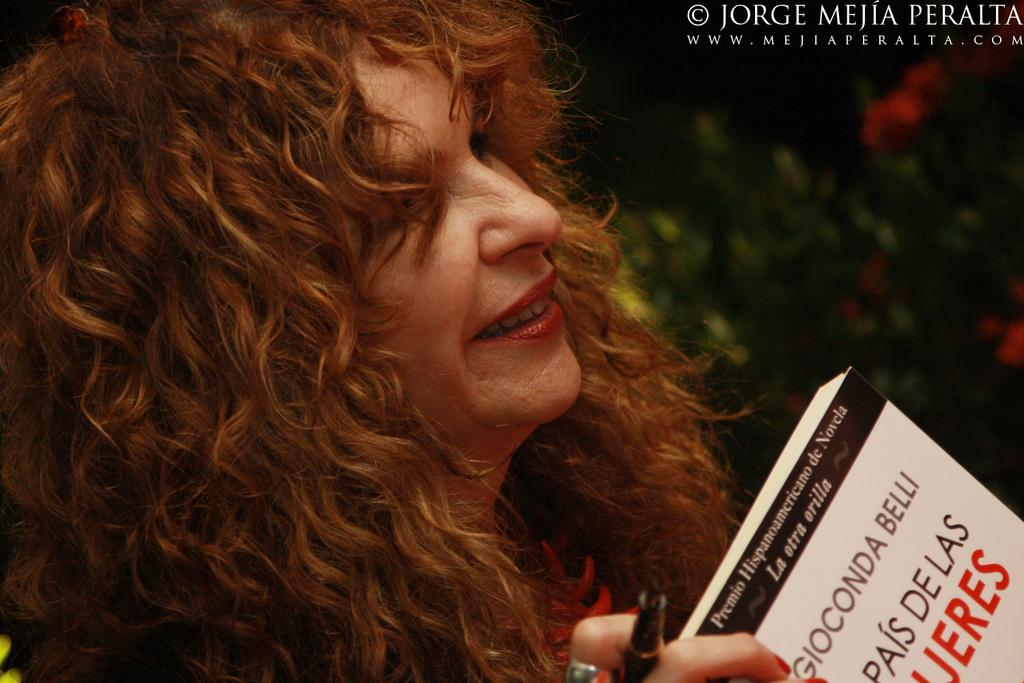What is the person in the image doing? The person in the image is holding a book and a pen. What might the person be about to do with the book and pen? The person might be about to write or take notes in the book. What can be seen in the top right of the image? There is text in the top right of the image. How would you describe the background of the image? The background of the image is blurred. What type of beef is being cooked on the stove in the image? There is no stove or beef present in the image. 